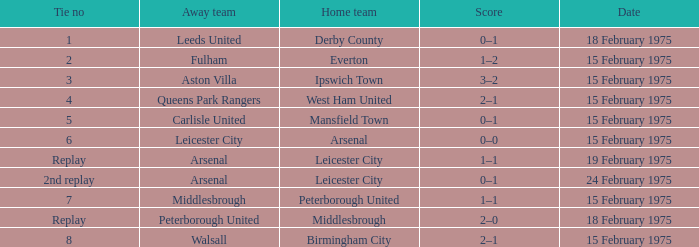What was the date when the away team was the leeds united? 18 February 1975. 